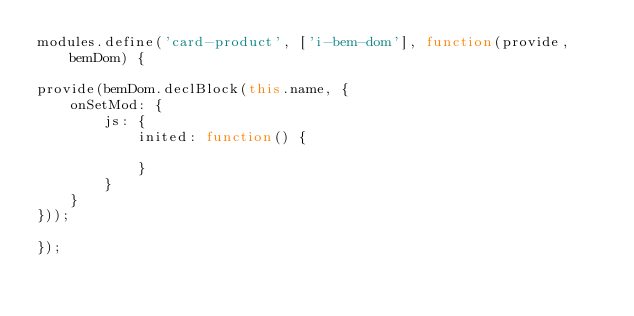Convert code to text. <code><loc_0><loc_0><loc_500><loc_500><_JavaScript_>modules.define('card-product', ['i-bem-dom'], function(provide, bemDom) {

provide(bemDom.declBlock(this.name, {
    onSetMod: {
        js: {
            inited: function() {
                
            }
        }
    }
}));

});
</code> 